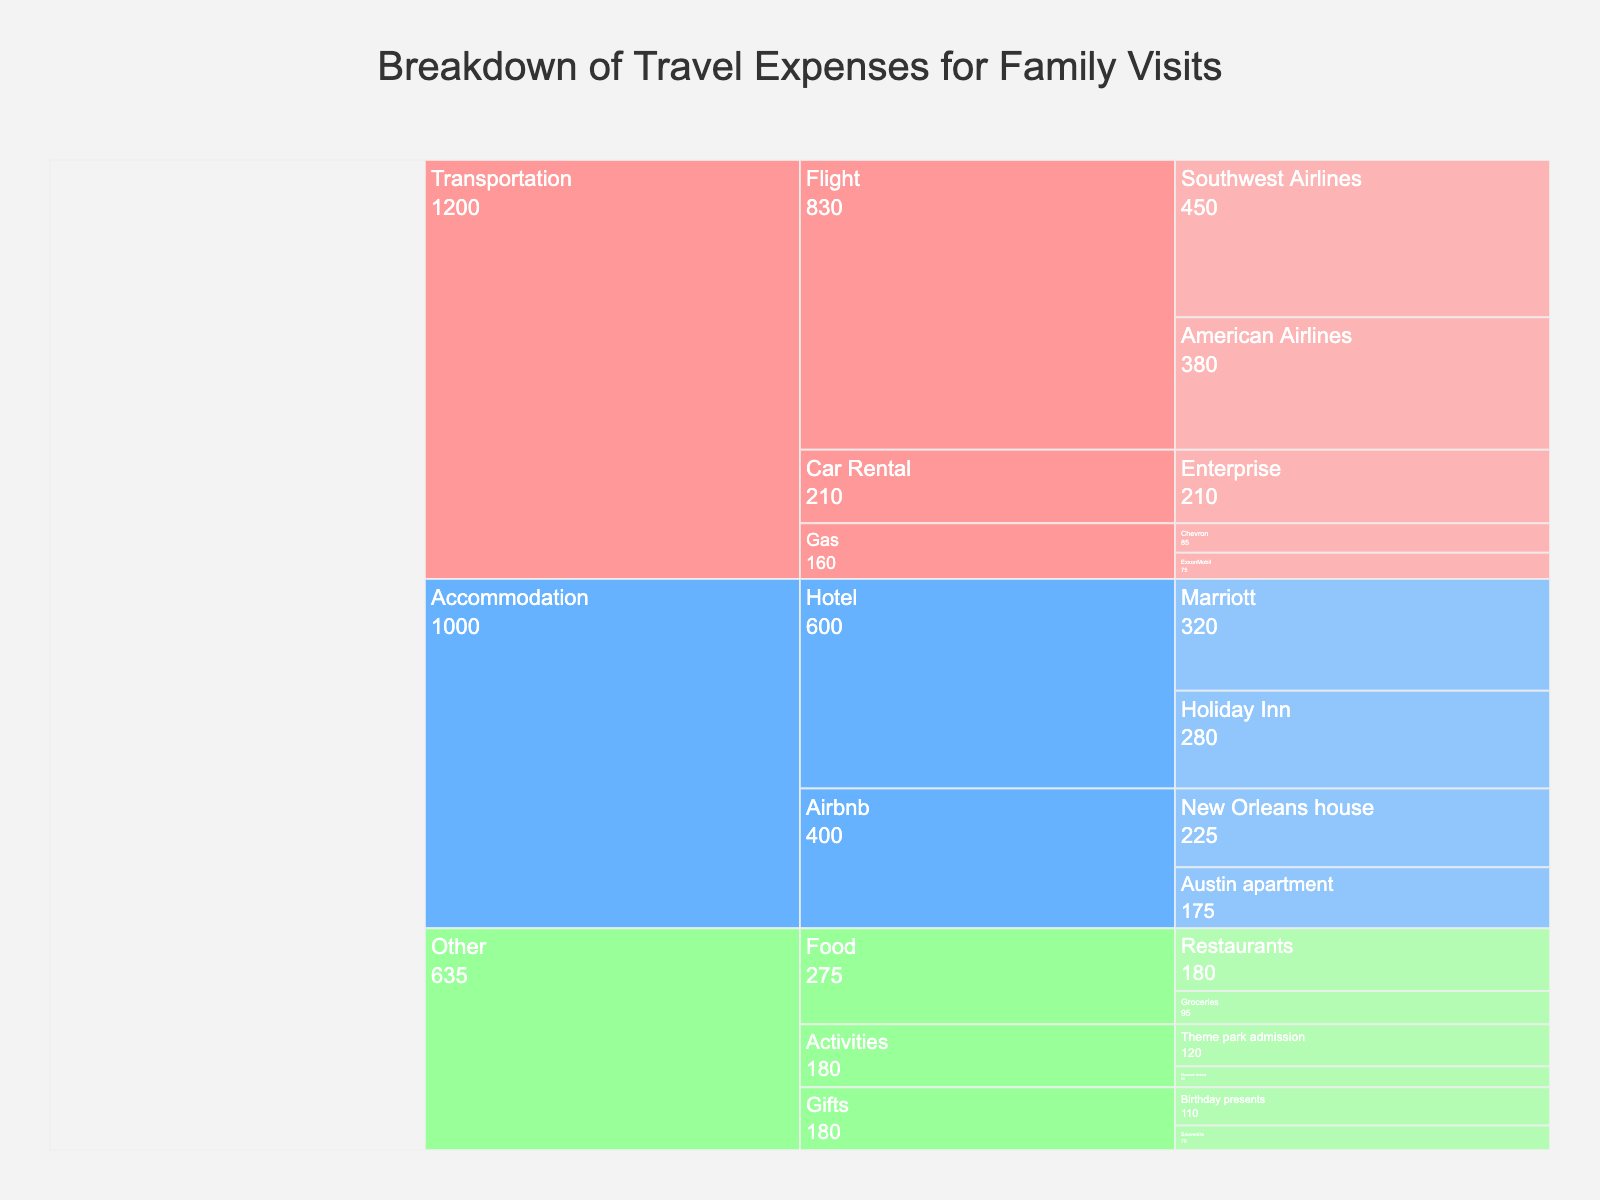what is the total cost of transportation expenses? To find the total cost of transportation expenses, look at the "Transportation" category and sum all the values associated with it: Southwest Airlines ($450), American Airlines ($380), Enterprise ($210), Chevron ($85), and ExxonMobil ($75). The sum is 450 + 380 + 210 + 85 + 75 = 1200.
Answer: $1200 what is the most expensive item in the "Other" category? To identify the most expensive item in the "Other" category, look at all the items under "Other" and their respective costs. The costs are Restaurants ($180), Groceries ($95), Museum tickets ($60), Theme park admission ($120), Souvenirs ($70), and Birthday presents ($110). The most expensive item is Restaurants with a cost of $180.
Answer: Restaurants how much more expensive are the total flight expenses compared to car rental expenses? First, calculate the total flight expenses by adding the costs of Southwest Airlines ($450) and American Airlines ($380), which equals $830. The car rental expense is $210. Subtract the car rental expense from the total flight expenses: 830 - 210 = 620.
Answer: $620 which accommodation category has the higher total cost, hotels or Airbnbs? Sum the costs for hotels and Airbnbs separately. For hotels, it's Marriott ($320) + Holiday Inn ($280) = $600. For Airbnbs, it's Austin apartment ($175) + New Orleans house ($225) = $400. Hotels have a higher total cost: $600 vs. $400.
Answer: Hotels what is the combined cost of gas for transportation? Sum the costs of Chevron ($85) and ExxonMobil ($75) under the gas subcategory in transportation. The combined cost is 85 + 75 = 160.
Answer: $160 